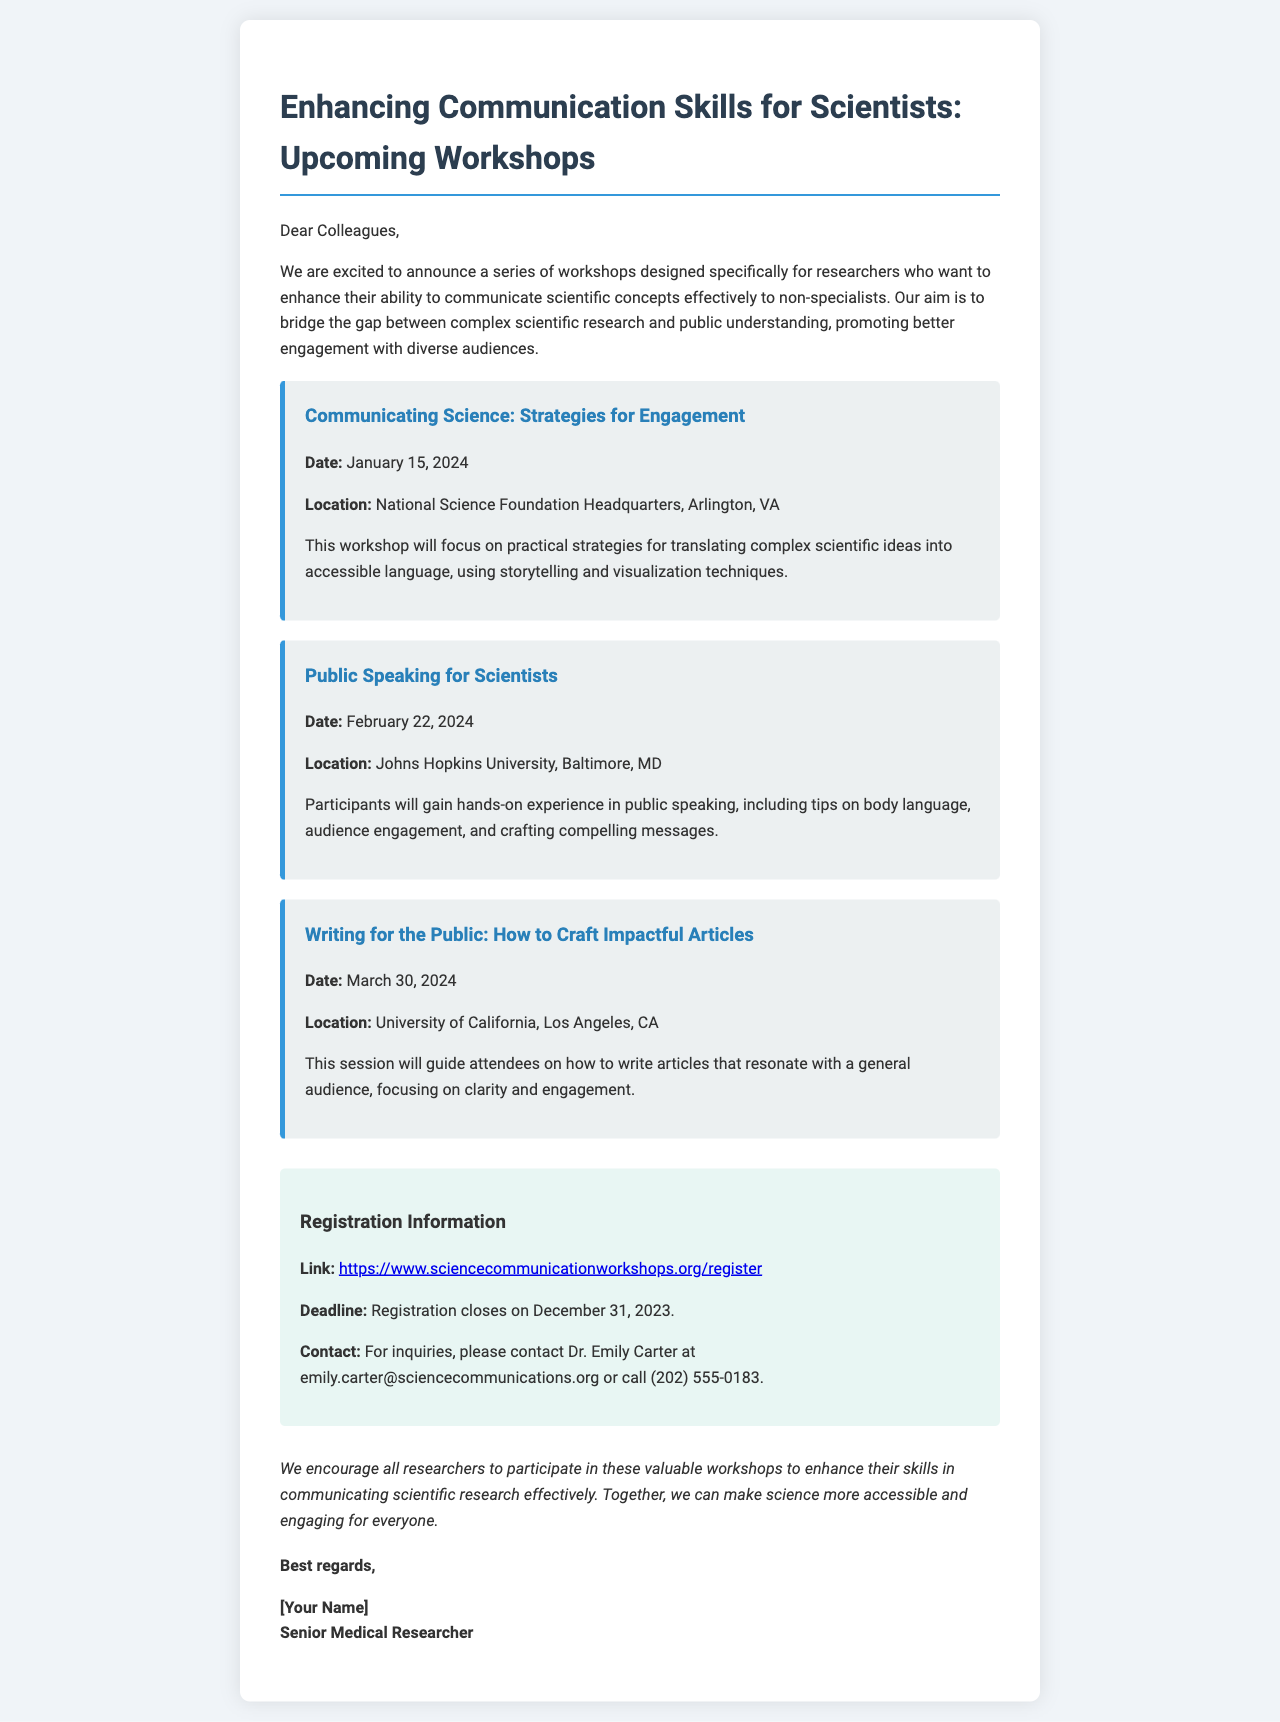What is the title of the first workshop? The title of the first workshop is specified in the document as "Communicating Science: Strategies for Engagement".
Answer: Communicating Science: Strategies for Engagement What is the date of the second workshop? The date of the second workshop is provided in the document as February 22, 2024.
Answer: February 22, 2024 Where is the last workshop located? The location of the last workshop is mentioned in the document as University of California, Los Angeles, CA.
Answer: University of California, Los Angeles, CA When does registration close? The document states that registration closes on December 31, 2023.
Answer: December 31, 2023 Who should be contacted for inquiries? The document specifies that inquiries should be directed to Dr. Emily Carter.
Answer: Dr. Emily Carter What is the purpose of the workshops? The document outlines that the workshops aim to enhance scientists' communication skills to non-specialists.
Answer: Enhance scientists' communication skills How many workshops are listed in the document? The document lists three workshops.
Answer: Three What is a key focus of the workshop on February 22, 2024? The document indicates that the focus is on public speaking, including tips on audience engagement.
Answer: Public speaking, audience engagement What type of event is being announced in the document? The document announces a series of workshops aimed at improving communication skills.
Answer: Workshops 